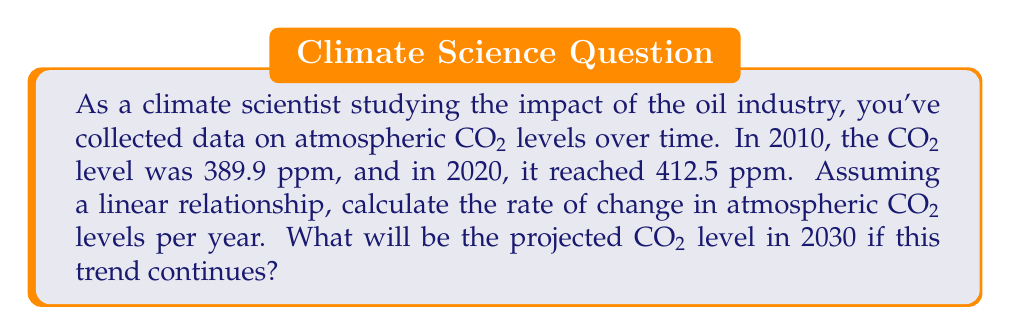Can you answer this question? Let's approach this step-by-step:

1) We can represent the CO2 level as a function of time using a linear equation:
   $$ y = mx + b $$
   where $y$ is the CO2 level in ppm, $x$ is the number of years since 2010, $m$ is the rate of change per year, and $b$ is the initial CO2 level in 2010.

2) We know two points on this line:
   (0, 389.9) for 2010
   (10, 412.5) for 2020

3) To find the rate of change $m$, we can use the slope formula:
   $$ m = \frac{y_2 - y_1}{x_2 - x_1} = \frac{412.5 - 389.9}{10 - 0} = \frac{22.6}{10} = 2.26 $$

4) So, the rate of change is 2.26 ppm per year.

5) Now, we can write our linear equation:
   $$ y = 2.26x + 389.9 $$

6) To project the CO2 level in 2030, we substitute $x = 20$ (20 years after 2010):
   $$ y = 2.26(20) + 389.9 = 45.2 + 389.9 = 435.1 $$

Therefore, the projected CO2 level in 2030 is 435.1 ppm.
Answer: Rate of change: 2.26 ppm/year; Projected 2030 CO2 level: 435.1 ppm 